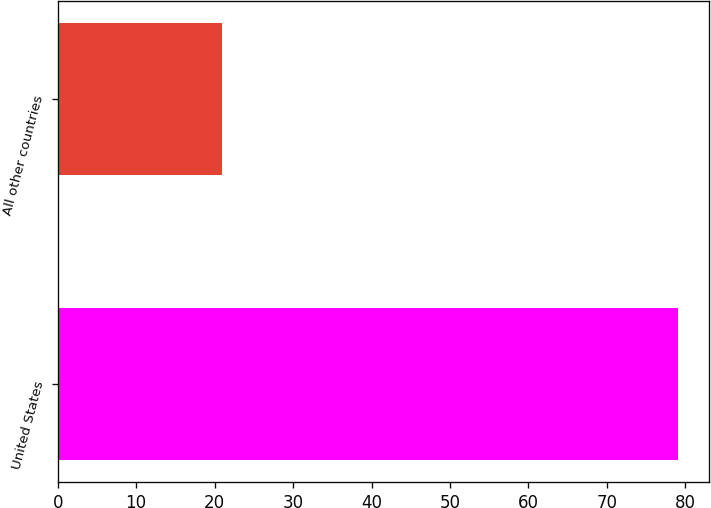<chart> <loc_0><loc_0><loc_500><loc_500><bar_chart><fcel>United States<fcel>All other countries<nl><fcel>79<fcel>21<nl></chart> 